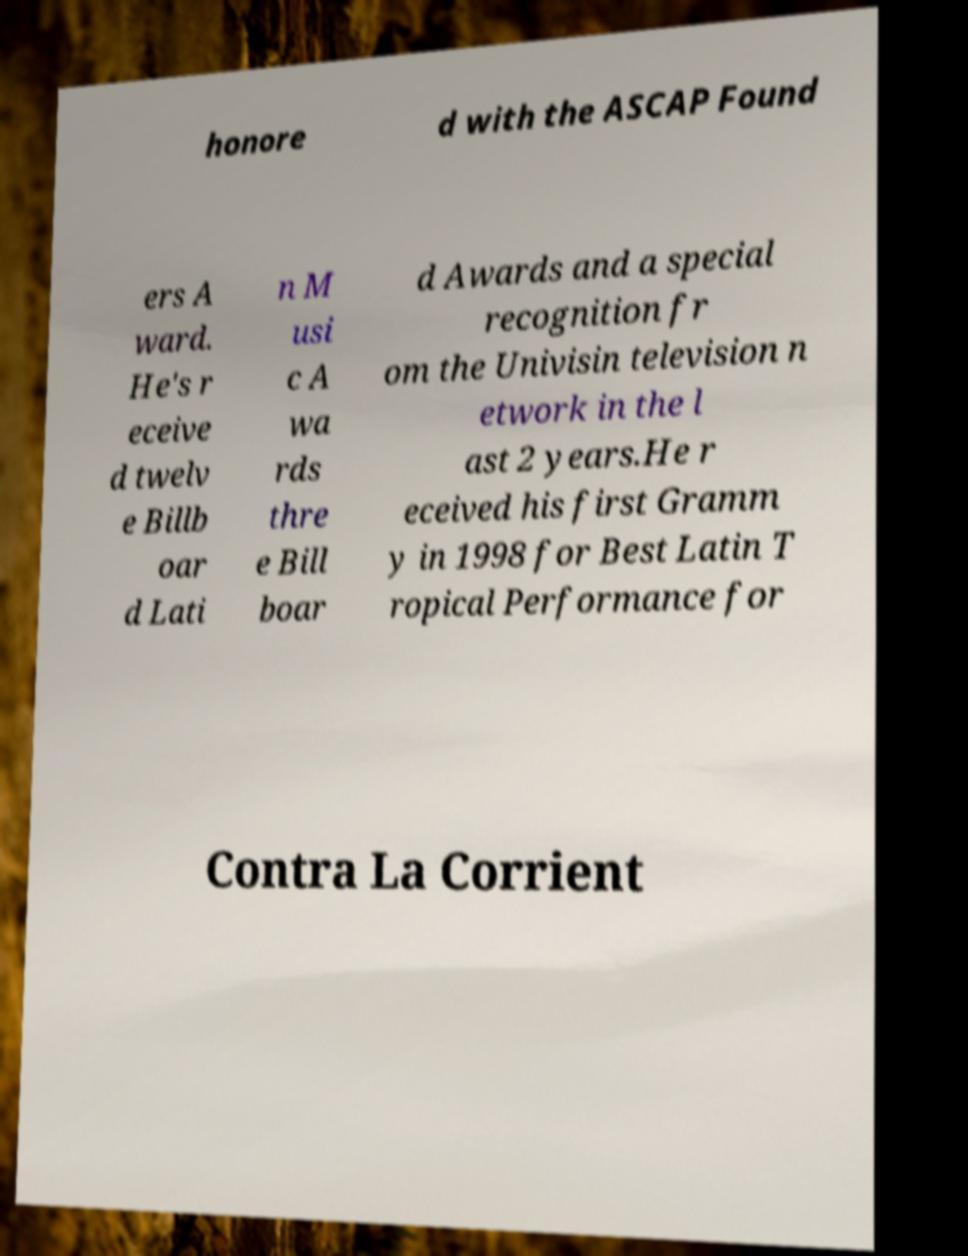Could you assist in decoding the text presented in this image and type it out clearly? honore d with the ASCAP Found ers A ward. He's r eceive d twelv e Billb oar d Lati n M usi c A wa rds thre e Bill boar d Awards and a special recognition fr om the Univisin television n etwork in the l ast 2 years.He r eceived his first Gramm y in 1998 for Best Latin T ropical Performance for Contra La Corrient 